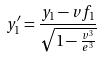<formula> <loc_0><loc_0><loc_500><loc_500>y _ { 1 } ^ { \prime } = \frac { y _ { 1 } - v f _ { 1 } } { \sqrt { 1 - \frac { v ^ { 3 } } { e ^ { 3 } } } }</formula> 